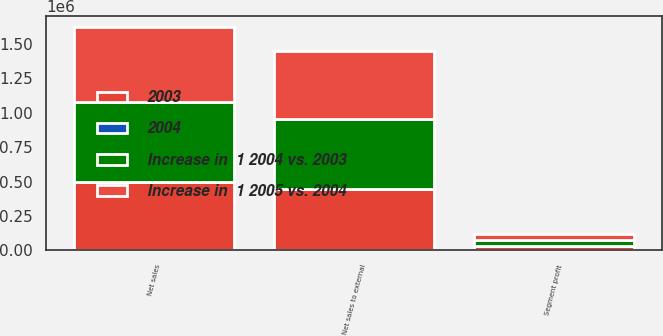Convert chart. <chart><loc_0><loc_0><loc_500><loc_500><stacked_bar_chart><ecel><fcel>Net sales<fcel>Net sales to external<fcel>Segment profit<nl><fcel>Increase in  1 2004 vs. 2003<fcel>577582<fcel>508289<fcel>45466<nl><fcel>Increase in  1 2005 vs. 2004<fcel>545366<fcel>494921<fcel>40185<nl><fcel>2003<fcel>499583<fcel>449322<fcel>30274<nl><fcel>2004<fcel>6<fcel>3<fcel>13<nl></chart> 